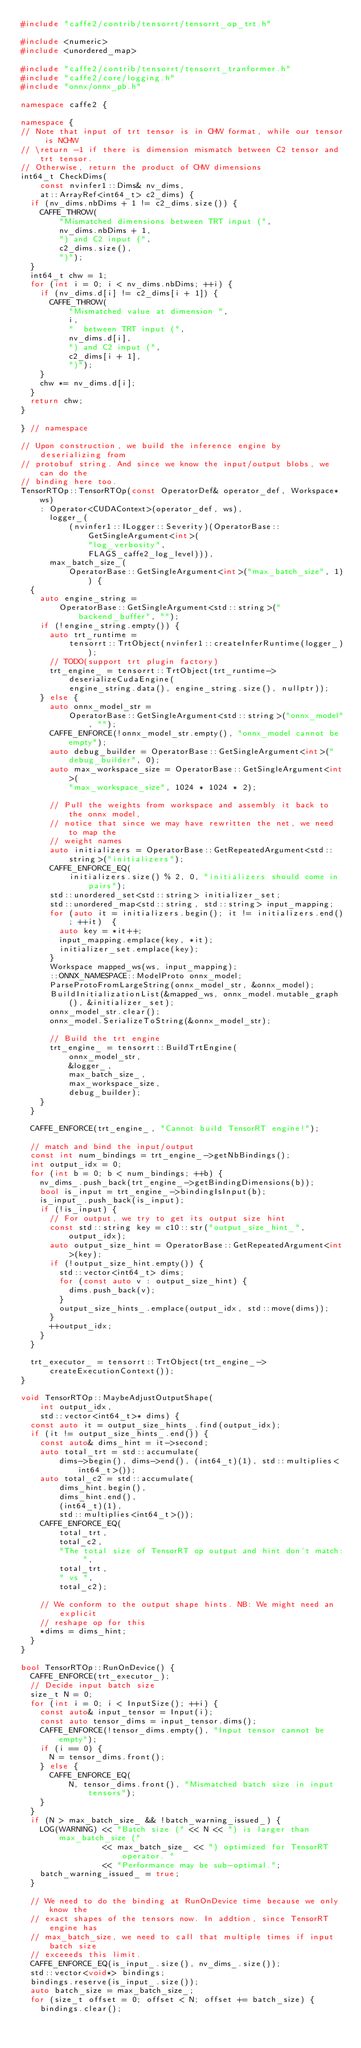Convert code to text. <code><loc_0><loc_0><loc_500><loc_500><_C++_>#include "caffe2/contrib/tensorrt/tensorrt_op_trt.h"

#include <numeric>
#include <unordered_map>

#include "caffe2/contrib/tensorrt/tensorrt_tranformer.h"
#include "caffe2/core/logging.h"
#include "onnx/onnx_pb.h"

namespace caffe2 {

namespace {
// Note that input of trt tensor is in CHW format, while our tensor is NCHW
// \return -1 if there is dimension mismatch between C2 tensor and trt tensor.
// Otherwise, return the product of CHW dimensions
int64_t CheckDims(
    const nvinfer1::Dims& nv_dims,
    at::ArrayRef<int64_t> c2_dims) {
  if (nv_dims.nbDims + 1 != c2_dims.size()) {
    CAFFE_THROW(
        "Mismatched dimensions between TRT input (",
        nv_dims.nbDims + 1,
        ") and C2 input (",
        c2_dims.size(),
        ")");
  }
  int64_t chw = 1;
  for (int i = 0; i < nv_dims.nbDims; ++i) {
    if (nv_dims.d[i] != c2_dims[i + 1]) {
      CAFFE_THROW(
          "Mismatched value at dimension ",
          i,
          "  between TRT input (",
          nv_dims.d[i],
          ") and C2 input (",
          c2_dims[i + 1],
          ")");
    }
    chw *= nv_dims.d[i];
  }
  return chw;
}

} // namespace

// Upon construction, we build the inference engine by deserializing from
// protobuf string. And since we know the input/output blobs, we can do the
// binding here too.
TensorRTOp::TensorRTOp(const OperatorDef& operator_def, Workspace* ws)
    : Operator<CUDAContext>(operator_def, ws),
      logger_(
          (nvinfer1::ILogger::Severity)(OperatorBase::GetSingleArgument<int>(
              "log_verbosity",
              FLAGS_caffe2_log_level))),
      max_batch_size_(
          OperatorBase::GetSingleArgument<int>("max_batch_size", 1)) {
  {
    auto engine_string =
        OperatorBase::GetSingleArgument<std::string>("backend_buffer", "");
    if (!engine_string.empty()) {
      auto trt_runtime =
          tensorrt::TrtObject(nvinfer1::createInferRuntime(logger_));
      // TODO(support trt plugin factory)
      trt_engine_ = tensorrt::TrtObject(trt_runtime->deserializeCudaEngine(
          engine_string.data(), engine_string.size(), nullptr));
    } else {
      auto onnx_model_str =
          OperatorBase::GetSingleArgument<std::string>("onnx_model", "");
      CAFFE_ENFORCE(!onnx_model_str.empty(), "onnx_model cannot be empty");
      auto debug_builder = OperatorBase::GetSingleArgument<int>("debug_builder", 0);
      auto max_workspace_size = OperatorBase::GetSingleArgument<int>(
          "max_workspace_size", 1024 * 1024 * 2);

      // Pull the weights from workspace and assembly it back to the onnx model,
      // notice that since we may have rewritten the net, we need to map the
      // weight names
      auto initializers = OperatorBase::GetRepeatedArgument<std::string>("initializers");
      CAFFE_ENFORCE_EQ(
          initializers.size() % 2, 0, "initializers should come in pairs");
      std::unordered_set<std::string> initializer_set;
      std::unordered_map<std::string, std::string> input_mapping;
      for (auto it = initializers.begin(); it != initializers.end(); ++it)  {
        auto key = *it++;
        input_mapping.emplace(key, *it);
        initializer_set.emplace(key);
      }
      Workspace mapped_ws(ws, input_mapping);
      ::ONNX_NAMESPACE::ModelProto onnx_model;
      ParseProtoFromLargeString(onnx_model_str, &onnx_model);
      BuildInitializationList(&mapped_ws, onnx_model.mutable_graph(), &initializer_set);
      onnx_model_str.clear();
      onnx_model.SerializeToString(&onnx_model_str);

      // Build the trt engine
      trt_engine_ = tensorrt::BuildTrtEngine(
          onnx_model_str,
          &logger_,
          max_batch_size_,
          max_workspace_size,
          debug_builder);
    }
  }

  CAFFE_ENFORCE(trt_engine_, "Cannot build TensorRT engine!");

  // match and bind the input/output
  const int num_bindings = trt_engine_->getNbBindings();
  int output_idx = 0;
  for (int b = 0; b < num_bindings; ++b) {
    nv_dims_.push_back(trt_engine_->getBindingDimensions(b));
    bool is_input = trt_engine_->bindingIsInput(b);
    is_input_.push_back(is_input);
    if (!is_input) {
      // For output, we try to get its output size hint
      const std::string key = c10::str("output_size_hint_", output_idx);
      auto output_size_hint = OperatorBase::GetRepeatedArgument<int>(key);
      if (!output_size_hint.empty()) {
        std::vector<int64_t> dims;
        for (const auto v : output_size_hint) {
          dims.push_back(v);
        }
        output_size_hints_.emplace(output_idx, std::move(dims));
      }
      ++output_idx;
    }
  }

  trt_executor_ = tensorrt::TrtObject(trt_engine_->createExecutionContext());
}

void TensorRTOp::MaybeAdjustOutputShape(
    int output_idx,
    std::vector<int64_t>* dims) {
  const auto it = output_size_hints_.find(output_idx);
  if (it != output_size_hints_.end()) {
    const auto& dims_hint = it->second;
    auto total_trt = std::accumulate(
        dims->begin(), dims->end(), (int64_t)(1), std::multiplies<int64_t>());
    auto total_c2 = std::accumulate(
        dims_hint.begin(),
        dims_hint.end(),
        (int64_t)(1),
        std::multiplies<int64_t>());
    CAFFE_ENFORCE_EQ(
        total_trt,
        total_c2,
        "The total size of TensorRT op output and hint don't match: ",
        total_trt,
        " vs ",
        total_c2);

    // We conform to the output shape hints. NB: We might need an explicit
    // reshape op for this
    *dims = dims_hint;
  }
}

bool TensorRTOp::RunOnDevice() {
  CAFFE_ENFORCE(trt_executor_);
  // Decide input batch size
  size_t N = 0;
  for (int i = 0; i < InputSize(); ++i) {
    const auto& input_tensor = Input(i);
    const auto tensor_dims = input_tensor.dims();
    CAFFE_ENFORCE(!tensor_dims.empty(), "Input tensor cannot be empty");
    if (i == 0) {
      N = tensor_dims.front();
    } else {
      CAFFE_ENFORCE_EQ(
          N, tensor_dims.front(), "Mismatched batch size in input tensors");
    }
  }
  if (N > max_batch_size_ && !batch_warning_issued_) {
    LOG(WARNING) << "Batch size (" << N << ") is larger than max_batch_size ("
                 << max_batch_size_ << ") optimized for TensorRT operator. "
                 << "Performance may be sub-optimal.";
    batch_warning_issued_ = true;
  }

  // We need to do the binding at RunOnDevice time because we only know the
  // exact shapes of the tensors now. In addtion, since TensorRT engine has
  // max_batch_size, we need to call that multiple times if input batch size
  // exceeeds this limit.
  CAFFE_ENFORCE_EQ(is_input_.size(), nv_dims_.size());
  std::vector<void*> bindings;
  bindings.reserve(is_input_.size());
  auto batch_size = max_batch_size_;
  for (size_t offset = 0; offset < N; offset += batch_size) {
    bindings.clear();</code> 